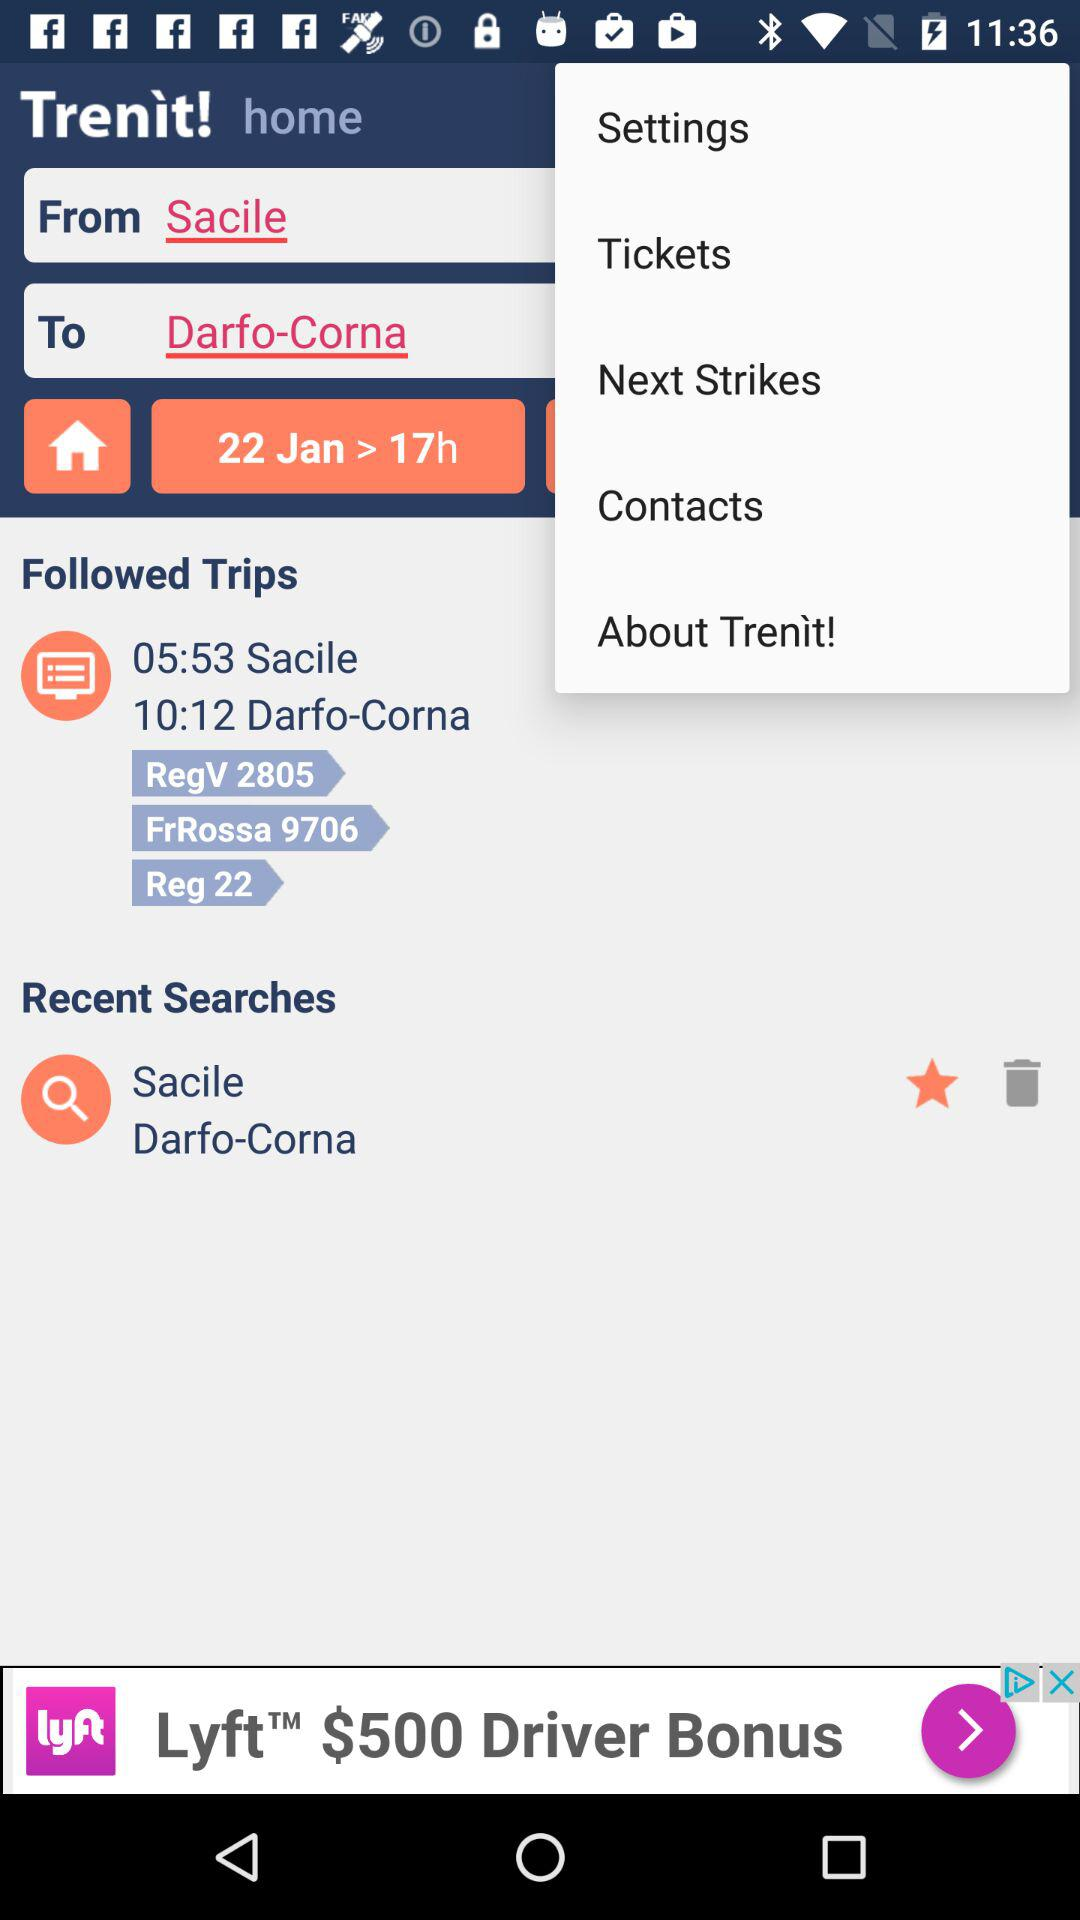What's the Duration of the trip?
When the provided information is insufficient, respond with <no answer>. <no answer> 